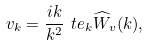<formula> <loc_0><loc_0><loc_500><loc_500>v _ { k } = \frac { i k } { k ^ { 2 } } \ t e _ { k } \widehat { W } _ { v } ( k ) ,</formula> 